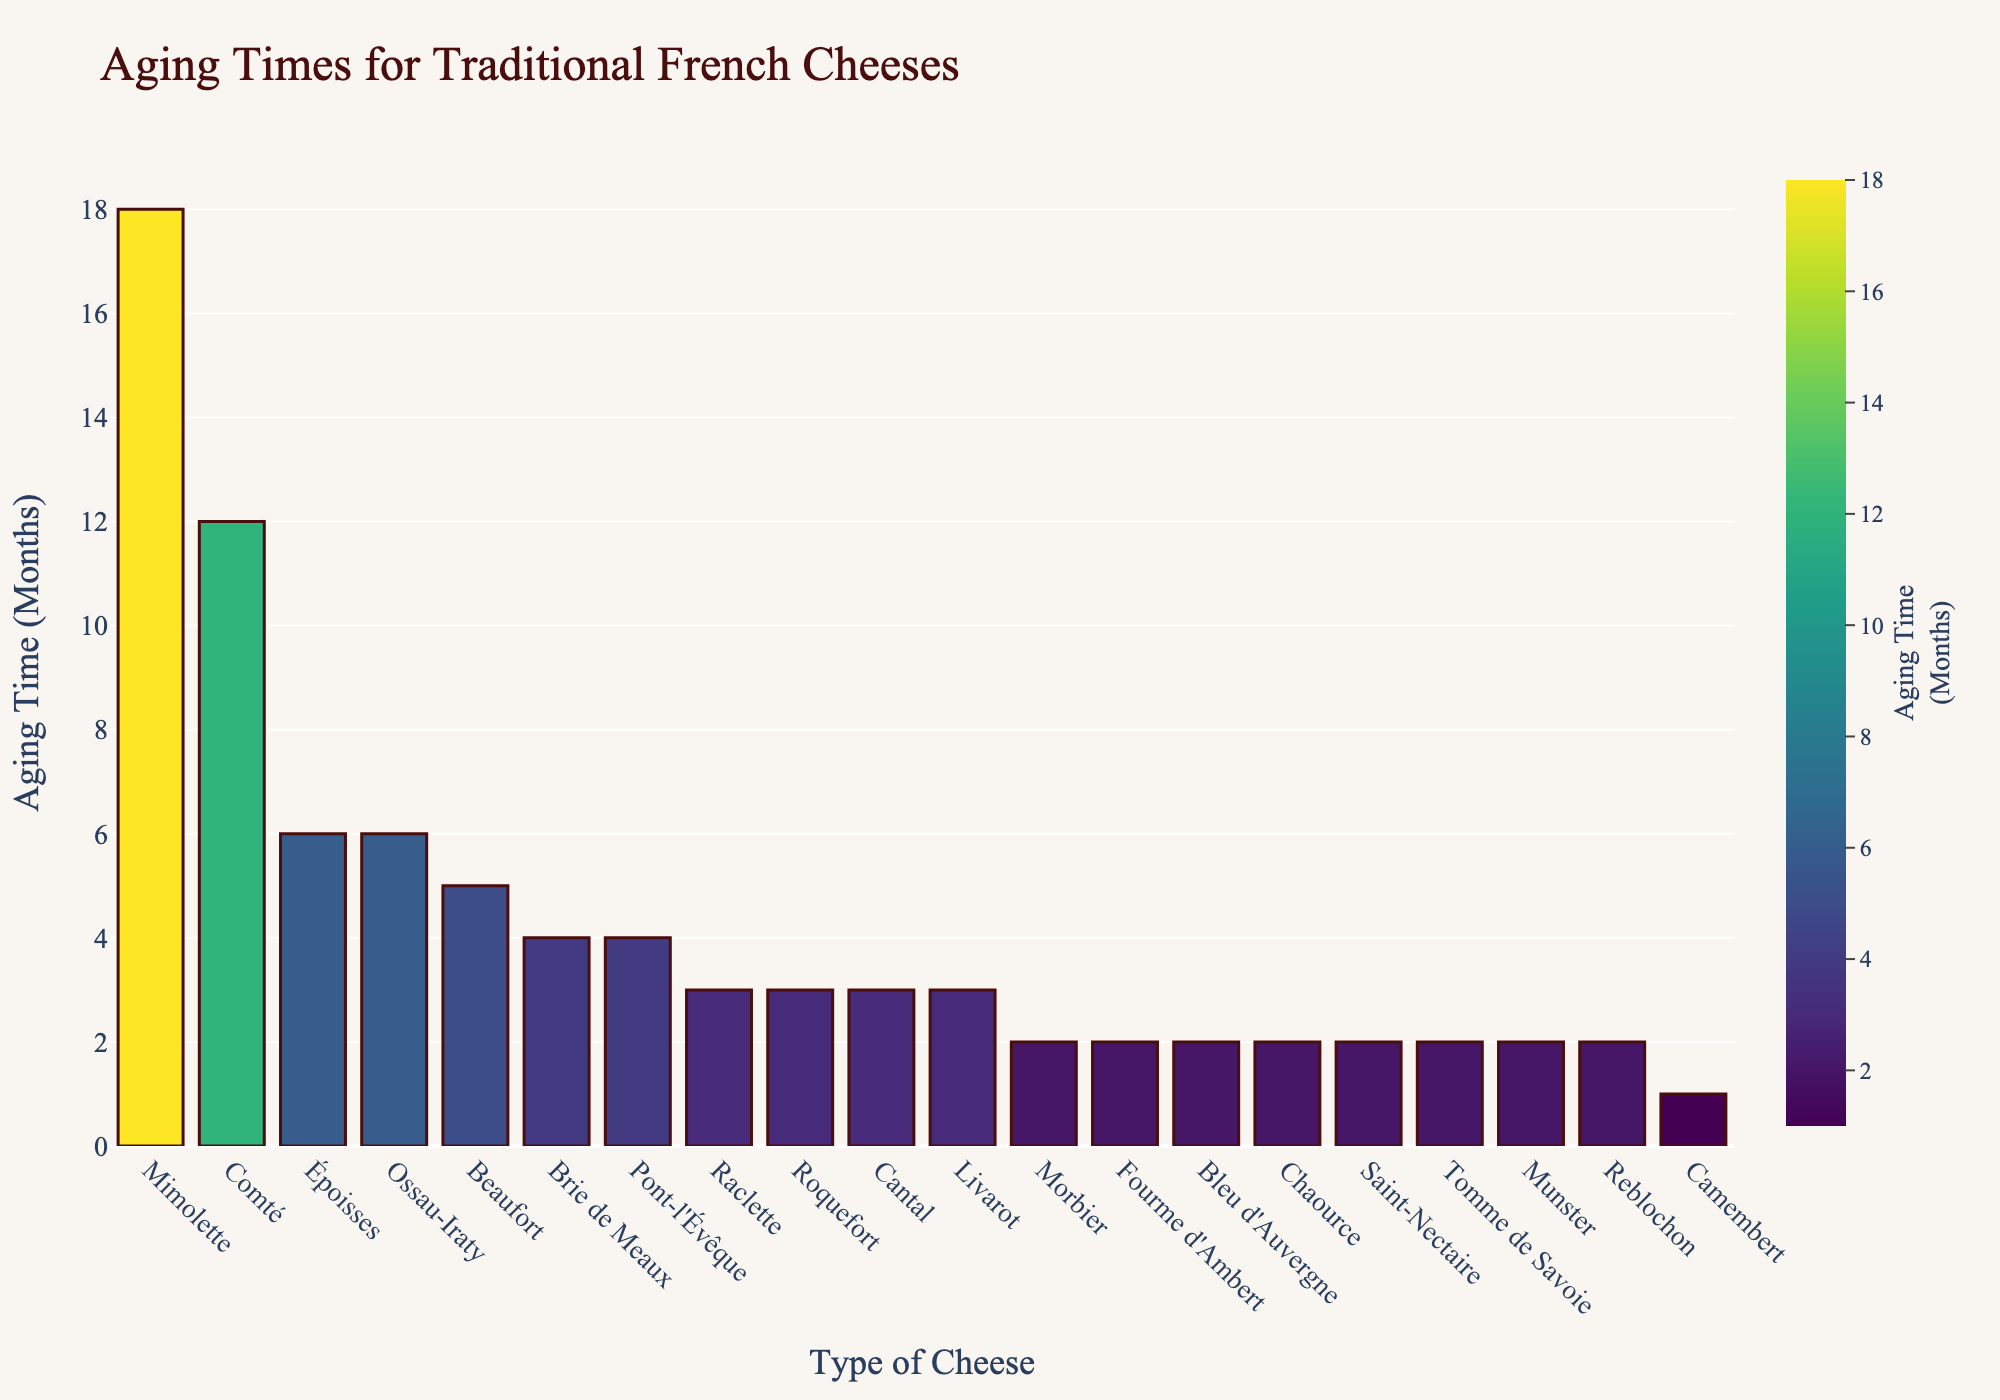Which cheese has the longest aging time? The cheese with the longest bar indicates the longest aging time. Mimolette has the longest aging time with a bar extending to 18 months.
Answer: Mimolette Which cheese has the shortest aging time? The cheese with the shortest bar indicates the shortest aging time. Camembert has the shortest aging time with a bar extending to 1 month.
Answer: Camembert How many cheeses have an aging time of exactly 2 months? Count the number of bars that reach exactly 2 months. There are 8 cheeses with an aging time of 2 months.
Answer: 8 What is the average aging time of all the cheeses listed? Sum up all the aging times and divide by the number of cheeses. The total aging time is 83 months (1+4+3+12+2+6+2+3+5+2+3+3+2+4+2+6+2+18+2+2) and there are 20 cheeses, so the average is 83 / 20 = 4.15 months.
Answer: 4.15 months Which cheeses have an aging time greater than 4 months? Identify the bars that extend beyond 4 months and list their corresponding cheeses. The cheeses are Comté, Époisses, Beaufort, Ossau-Iraty, and Mimolette.
Answer: Comté, Époisses, Beaufort, Ossau-Iraty, Mimolette Compare the aging time of Brie de Meaux and Roquefort. Which one has a longer aging time? Observe the heights of the bars for Brie de Meaux and Roquefort. Brie de Meaux has an aging time of 4 months, while Roquefort has 3 months. Therefore, Brie de Meaux has a longer aging time.
Answer: Brie de Meaux What is the median aging time for the cheeses? Arrange the aging times in ascending order and find the middle value. The arranged aging times are 1, 2, 2, 2, 2, 2, 2, 2, 3, 3, 3, 3, 4, 4, 5, 6, 6, 12, 18. With 20 values, the median is the average of the 10th and 11th values: (3+3)/2 = 3 months.
Answer: 3 months What is the total aging time for cheeses with an aging time of 4 months or more? Sum the aging times of each cheese with aging times equal to or greater than 4 months. The cheeses with 4 or more months aging times are Brie de Meaux (4), Comté (12), Époisses (6), Beaufort (5), Pont-l'Évêque (4), Ossau-Iraty (6), and Mimolette (18). Total aging time is 4+12+6+5+4+6+18 = 55 months.
Answer: 55 months Which cheese has an aging time closest to the average aging time? Calculate the average aging time, which is 4.15 months. Find the cheese with an aging time closest to this value. Raclette, Reblochon, Roquefort, Cantal, Livarot, and Saint-Nectaire all have aging times around the average. The exact closest match is Raclette, Reblochon, Saint-Nectaire, and others with 2 months as there is no 4.15-month cheese.
Answer: Raclette, Reblochon, Saint-Nectaire, and others 